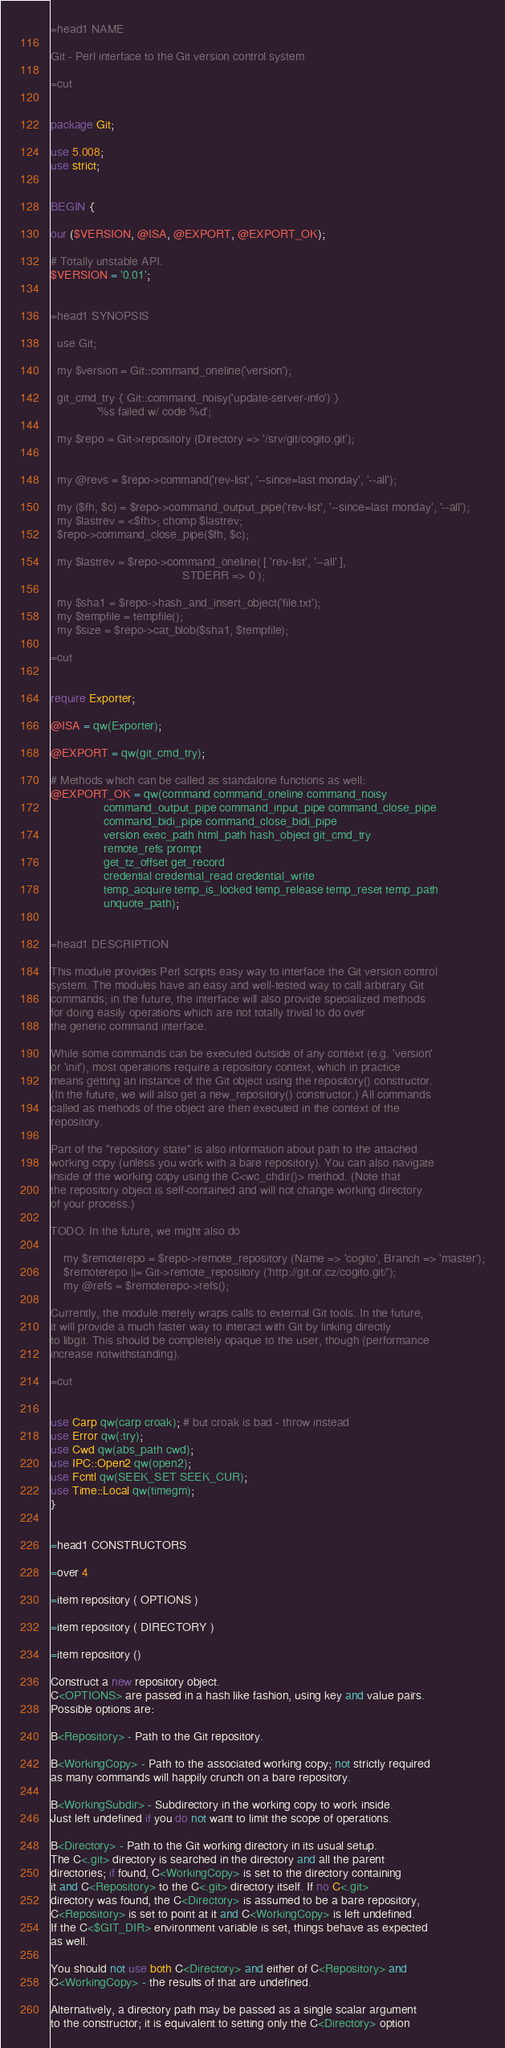Convert code to text. <code><loc_0><loc_0><loc_500><loc_500><_Perl_>=head1 NAME

Git - Perl interface to the Git version control system

=cut


package Git;

use 5.008;
use strict;


BEGIN {

our ($VERSION, @ISA, @EXPORT, @EXPORT_OK);

# Totally unstable API.
$VERSION = '0.01';


=head1 SYNOPSIS

  use Git;

  my $version = Git::command_oneline('version');

  git_cmd_try { Git::command_noisy('update-server-info') }
              '%s failed w/ code %d';

  my $repo = Git->repository (Directory => '/srv/git/cogito.git');


  my @revs = $repo->command('rev-list', '--since=last monday', '--all');

  my ($fh, $c) = $repo->command_output_pipe('rev-list', '--since=last monday', '--all');
  my $lastrev = <$fh>; chomp $lastrev;
  $repo->command_close_pipe($fh, $c);

  my $lastrev = $repo->command_oneline( [ 'rev-list', '--all' ],
                                        STDERR => 0 );

  my $sha1 = $repo->hash_and_insert_object('file.txt');
  my $tempfile = tempfile();
  my $size = $repo->cat_blob($sha1, $tempfile);

=cut


require Exporter;

@ISA = qw(Exporter);

@EXPORT = qw(git_cmd_try);

# Methods which can be called as standalone functions as well:
@EXPORT_OK = qw(command command_oneline command_noisy
                command_output_pipe command_input_pipe command_close_pipe
                command_bidi_pipe command_close_bidi_pipe
                version exec_path html_path hash_object git_cmd_try
                remote_refs prompt
                get_tz_offset get_record
                credential credential_read credential_write
                temp_acquire temp_is_locked temp_release temp_reset temp_path
                unquote_path);


=head1 DESCRIPTION

This module provides Perl scripts easy way to interface the Git version control
system. The modules have an easy and well-tested way to call arbitrary Git
commands; in the future, the interface will also provide specialized methods
for doing easily operations which are not totally trivial to do over
the generic command interface.

While some commands can be executed outside of any context (e.g. 'version'
or 'init'), most operations require a repository context, which in practice
means getting an instance of the Git object using the repository() constructor.
(In the future, we will also get a new_repository() constructor.) All commands
called as methods of the object are then executed in the context of the
repository.

Part of the "repository state" is also information about path to the attached
working copy (unless you work with a bare repository). You can also navigate
inside of the working copy using the C<wc_chdir()> method. (Note that
the repository object is self-contained and will not change working directory
of your process.)

TODO: In the future, we might also do

	my $remoterepo = $repo->remote_repository (Name => 'cogito', Branch => 'master');
	$remoterepo ||= Git->remote_repository ('http://git.or.cz/cogito.git/');
	my @refs = $remoterepo->refs();

Currently, the module merely wraps calls to external Git tools. In the future,
it will provide a much faster way to interact with Git by linking directly
to libgit. This should be completely opaque to the user, though (performance
increase notwithstanding).

=cut


use Carp qw(carp croak); # but croak is bad - throw instead
use Error qw(:try);
use Cwd qw(abs_path cwd);
use IPC::Open2 qw(open2);
use Fcntl qw(SEEK_SET SEEK_CUR);
use Time::Local qw(timegm);
}


=head1 CONSTRUCTORS

=over 4

=item repository ( OPTIONS )

=item repository ( DIRECTORY )

=item repository ()

Construct a new repository object.
C<OPTIONS> are passed in a hash like fashion, using key and value pairs.
Possible options are:

B<Repository> - Path to the Git repository.

B<WorkingCopy> - Path to the associated working copy; not strictly required
as many commands will happily crunch on a bare repository.

B<WorkingSubdir> - Subdirectory in the working copy to work inside.
Just left undefined if you do not want to limit the scope of operations.

B<Directory> - Path to the Git working directory in its usual setup.
The C<.git> directory is searched in the directory and all the parent
directories; if found, C<WorkingCopy> is set to the directory containing
it and C<Repository> to the C<.git> directory itself. If no C<.git>
directory was found, the C<Directory> is assumed to be a bare repository,
C<Repository> is set to point at it and C<WorkingCopy> is left undefined.
If the C<$GIT_DIR> environment variable is set, things behave as expected
as well.

You should not use both C<Directory> and either of C<Repository> and
C<WorkingCopy> - the results of that are undefined.

Alternatively, a directory path may be passed as a single scalar argument
to the constructor; it is equivalent to setting only the C<Directory> option</code> 